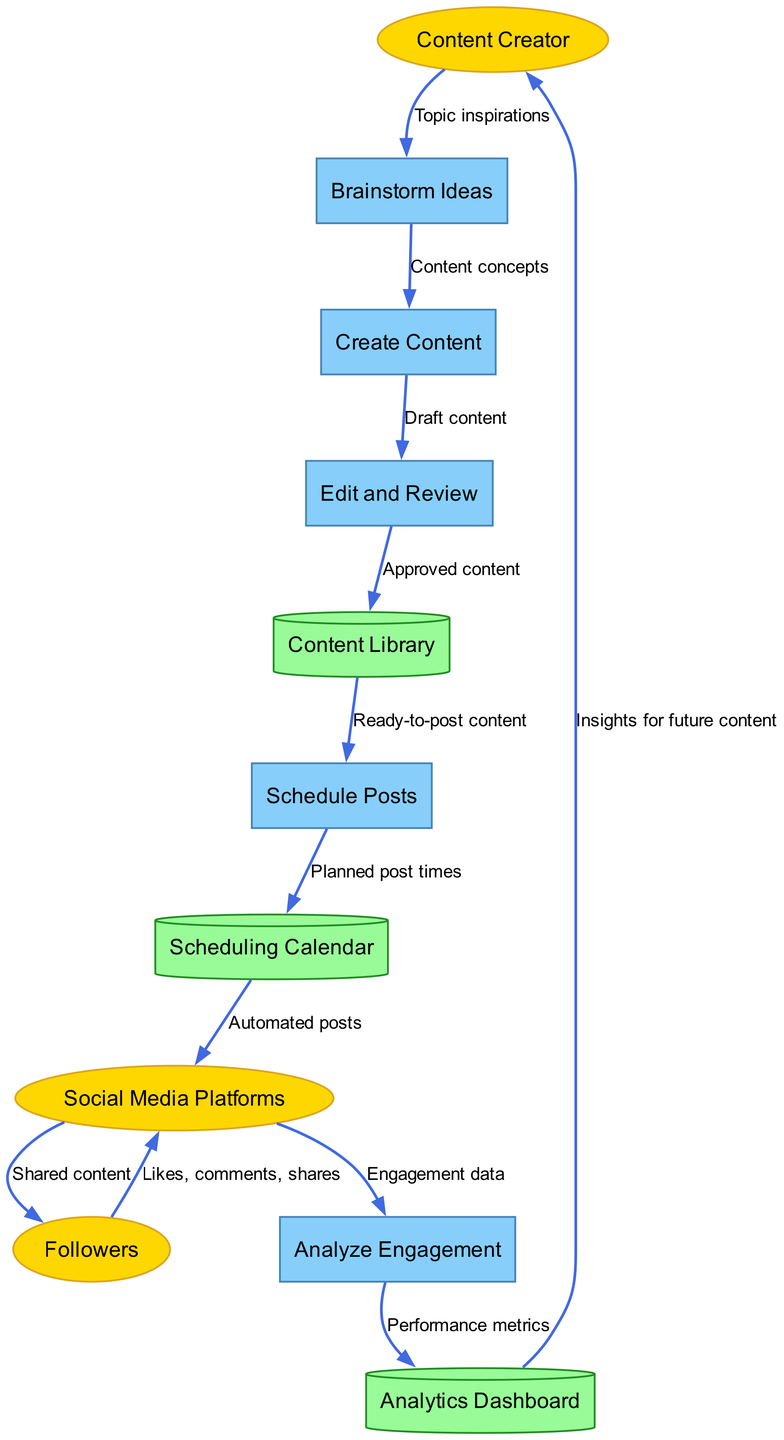What is the first process in the workflow? The first process listed in the diagram is "Brainstorm Ideas," which is the starting point for the content creation workflow.
Answer: Brainstorm Ideas How many external entities are there in the diagram? The diagram identifies three external entities: Content Creator, Followers, and Social Media Platforms.
Answer: Three Which process follows "Edit and Review"? The process that directly follows "Edit and Review" is "Content Library," where approved content is stored after review.
Answer: Content Library What type of data store is "Scheduling Calendar"? "Scheduling Calendar" is categorized as a data store in the diagram, specifically represented as a cylinder, indicating its role in storing scheduling data.
Answer: Cylinder How many total processes are involved in the social media content creation workflow? There are five total processes identified in the diagram: Brainstorm Ideas, Create Content, Edit and Review, Schedule Posts, and Analyze Engagement.
Answer: Five What type of flow is indicated between "Social Media Platforms" and "Followers"? The flow between "Social Media Platforms" and "Followers" represents shared content that is being distributed from the platforms to their users.
Answer: Shared content What does the "Analytics Dashboard" provide to the "Content Creator"? The "Analytics Dashboard" provides insights for future content to the "Content Creator," helping them understand performance metrics.
Answer: Insights for future content What is the purpose of the "Analyze Engagement" process? The purpose of the "Analyze Engagement" process is to analyze the engagement data received from "Social Media Platforms." It helps assess how well the content performs.
Answer: Analyze engagement data Which process is responsible for scheduling posts? The process responsible for scheduling posts is "Schedule Posts," which organizes the planned post times based on the content prepared.
Answer: Schedule Posts 